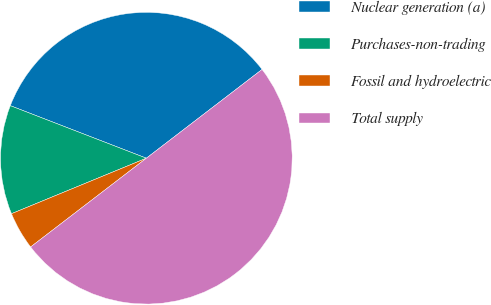Convert chart to OTSL. <chart><loc_0><loc_0><loc_500><loc_500><pie_chart><fcel>Nuclear generation (a)<fcel>Purchases-non-trading<fcel>Fossil and hydroelectric<fcel>Total supply<nl><fcel>33.72%<fcel>12.08%<fcel>4.2%<fcel>50.0%<nl></chart> 